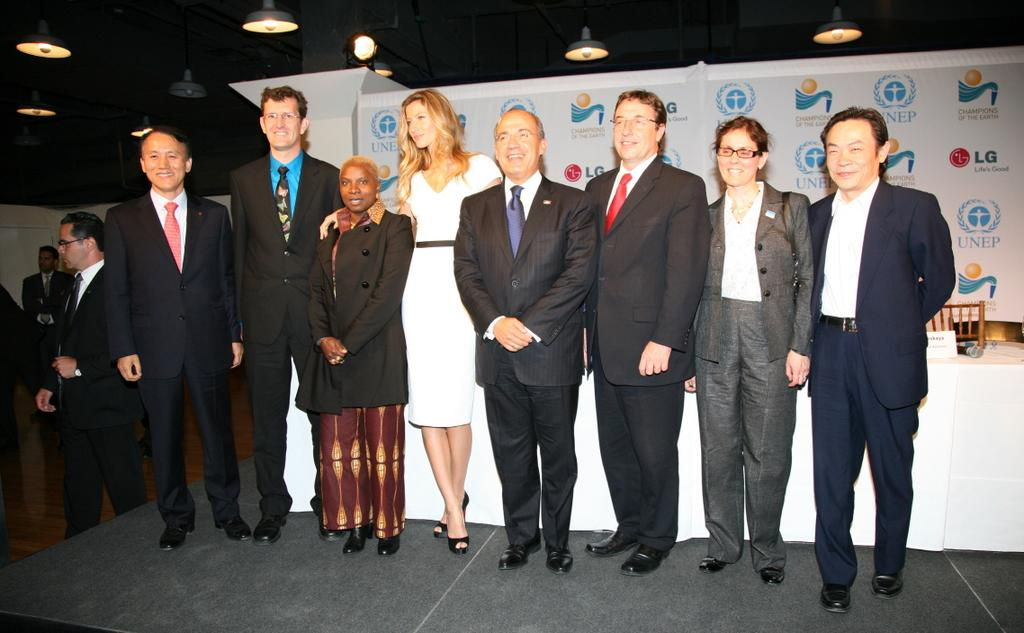How many people are in the image? There are persons in the image, but the exact number is not specified. What is the surface beneath the persons? There is a floor in the image. What illuminates the scene in the image? There are lights in the image. What objects can be seen in the background of the image? There is a table, cloth, a chair, and a banner in the background of the image. How many tomatoes are on the table in the image? There is no mention of tomatoes in the image, so we cannot determine their presence or quantity. What type of smile can be seen on the beggar's face in the image? There is no mention of a beggar or a smile in the image, so we cannot answer this question. 